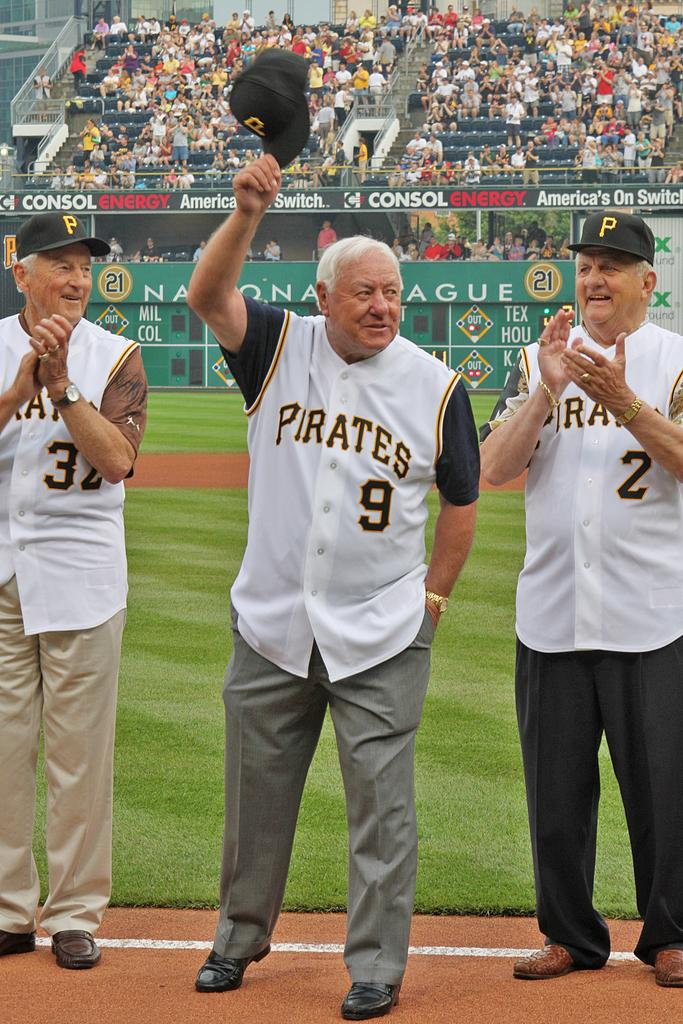<image>
Create a compact narrative representing the image presented. A group of three older gentleman with Pirates jerseys standing next to each other 